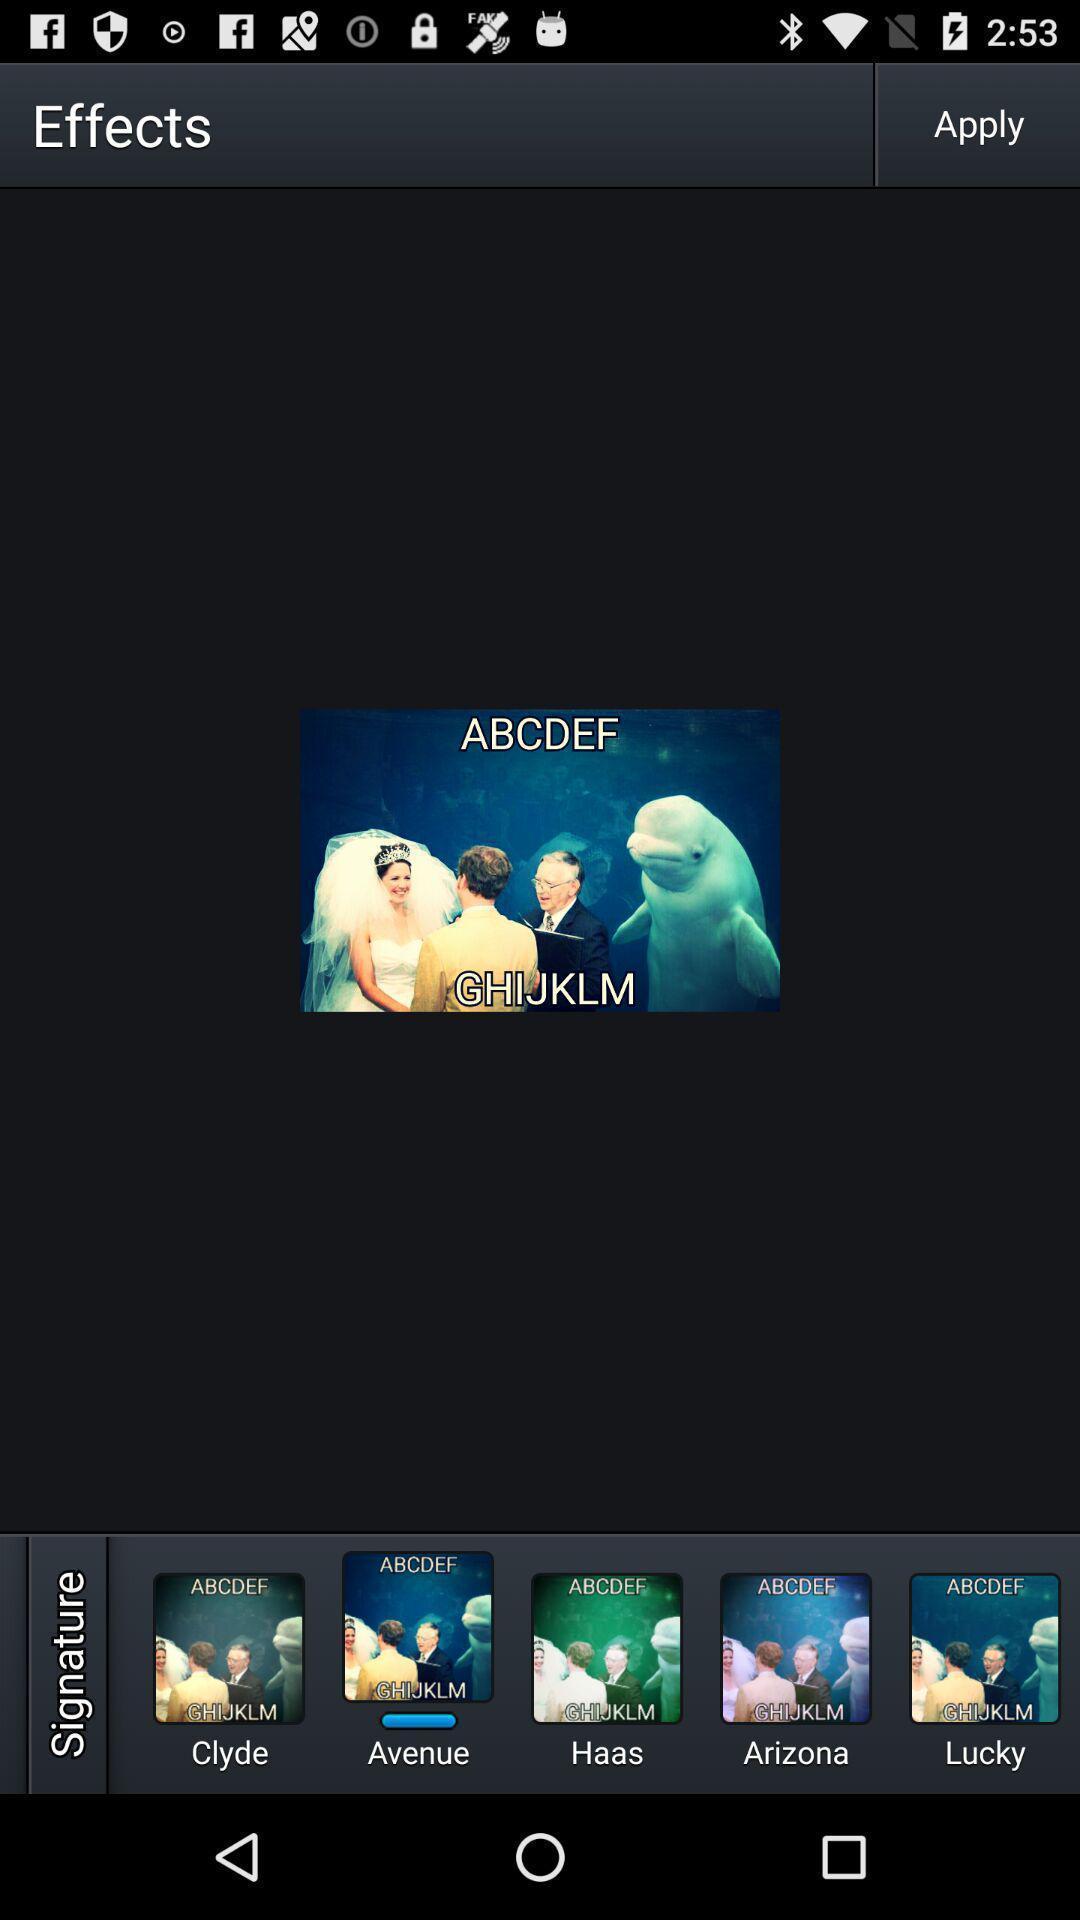Tell me about the visual elements in this screen capture. Page shows different editing effects in the photo edit app. 